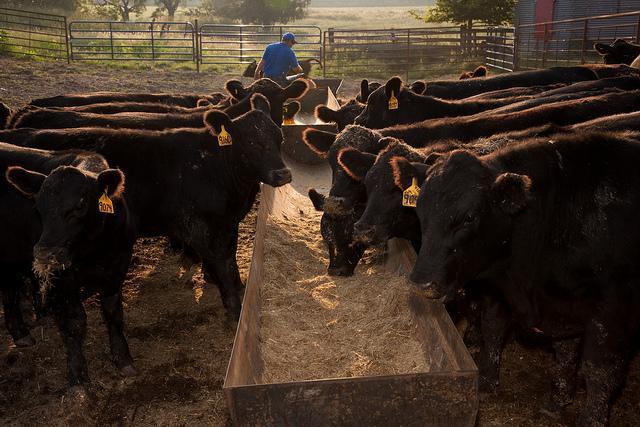How many cows can you see?
Give a very brief answer. 10. How many cars are in the photo?
Give a very brief answer. 0. 